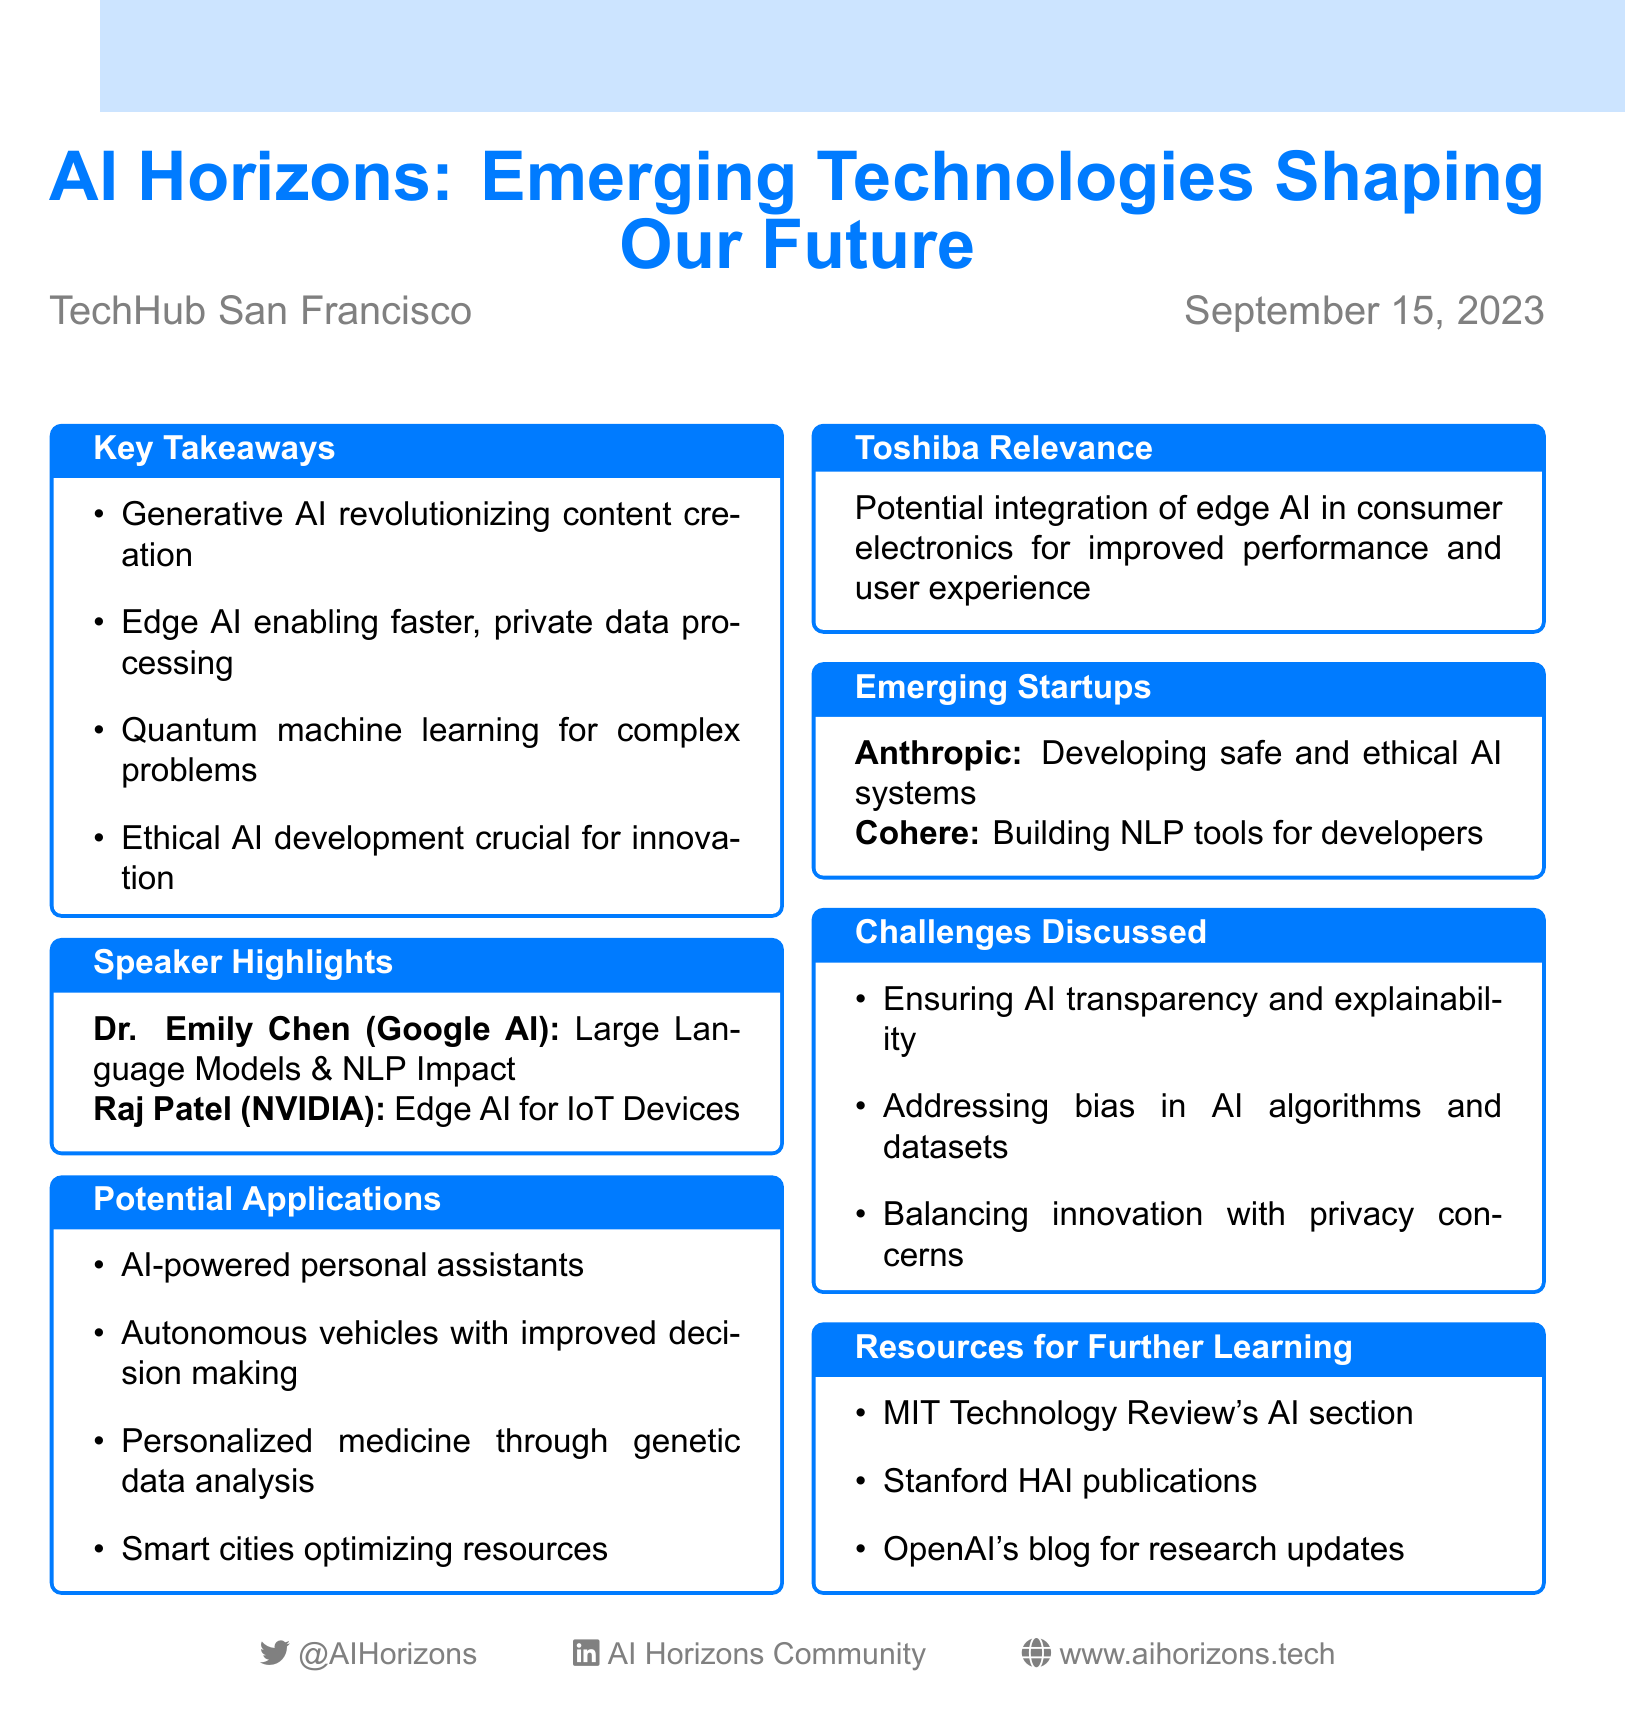What was the date of the meetup? The date of the meetup is explicitly stated in the document as September 15, 2023.
Answer: September 15, 2023 Who represented Google AI at the meetup? The speaker from Google AI at the meetup is specifically mentioned as Dr. Emily Chen.
Answer: Dr. Emily Chen What is one of the key takeaways regarding Generative AI? The document states that Generative AI is revolutionizing content creation, which is a key takeaway discussed at the meetup.
Answer: Revolutionizing content creation What are two potential applications of AI mentioned? Two potential applications listed in the document include AI-powered personal assistants and autonomous vehicles.
Answer: AI-powered personal assistants; autonomous vehicles Who is developing safe and ethical AI systems? The company mentioned in the document that is focused on developing safe and ethical AI systems is Anthropic.
Answer: Anthropic What is a challenge discussed at the meetup? One of the challenges outlined in the document is ensuring AI transparency and explainability.
Answer: Ensuring AI transparency and explainability What is Toshiba's relevance to the discussions? The document notes that Toshiba's relevance is about the potential integration of edge AI in their consumer electronics.
Answer: Integration of edge AI in consumer electronics What resources are recommended for further learning? The document lists several resources, including MIT Technology Review's AI section and Stanford HAI publications, as recommended resources.
Answer: MIT Technology Review's AI section; Stanford HAI publications 